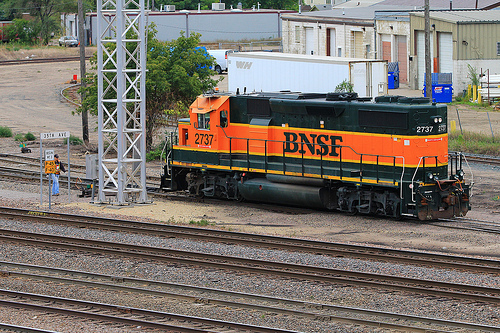Can you describe the weather or time of day in the image? The overcast sky suggests it might be a cloudy day. The lighting does not indicate any strong shadows, which makes it difficult to determine the precise time of day, but it appears to be daytime. 